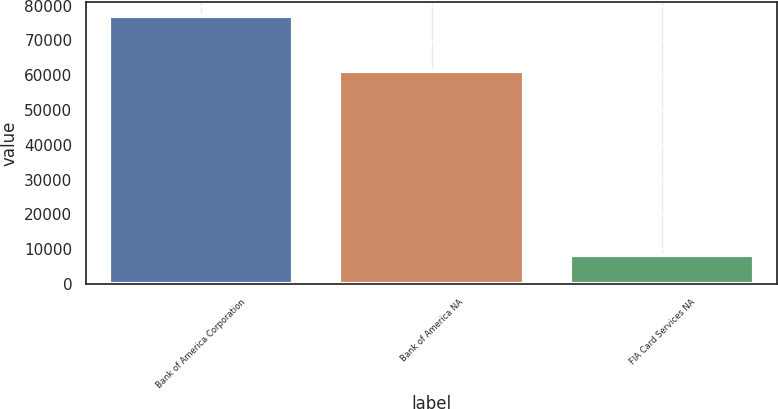Convert chart. <chart><loc_0><loc_0><loc_500><loc_500><bar_chart><fcel>Bank of America Corporation<fcel>Bank of America NA<fcel>FIA Card Services NA<nl><fcel>77068<fcel>61245<fcel>8393<nl></chart> 